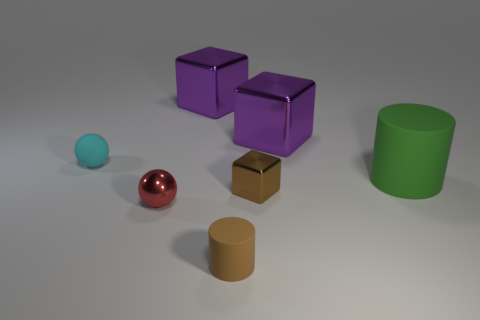Add 2 matte cylinders. How many objects exist? 9 Subtract all spheres. How many objects are left? 5 Subtract 2 purple cubes. How many objects are left? 5 Subtract all large brown shiny things. Subtract all metal cubes. How many objects are left? 4 Add 2 green rubber cylinders. How many green rubber cylinders are left? 3 Add 3 big purple things. How many big purple things exist? 5 